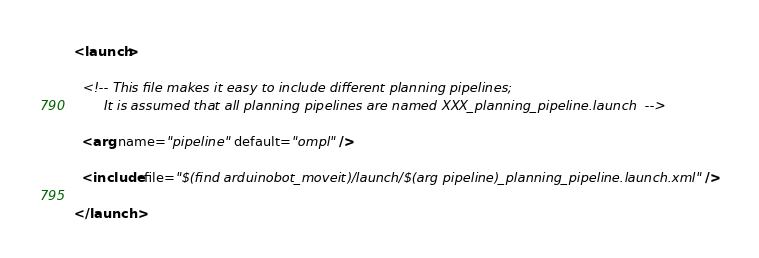<code> <loc_0><loc_0><loc_500><loc_500><_XML_><launch>

  <!-- This file makes it easy to include different planning pipelines;
       It is assumed that all planning pipelines are named XXX_planning_pipeline.launch  -->

  <arg name="pipeline" default="ompl" />

  <include file="$(find arduinobot_moveit)/launch/$(arg pipeline)_planning_pipeline.launch.xml" />

</launch>
</code> 